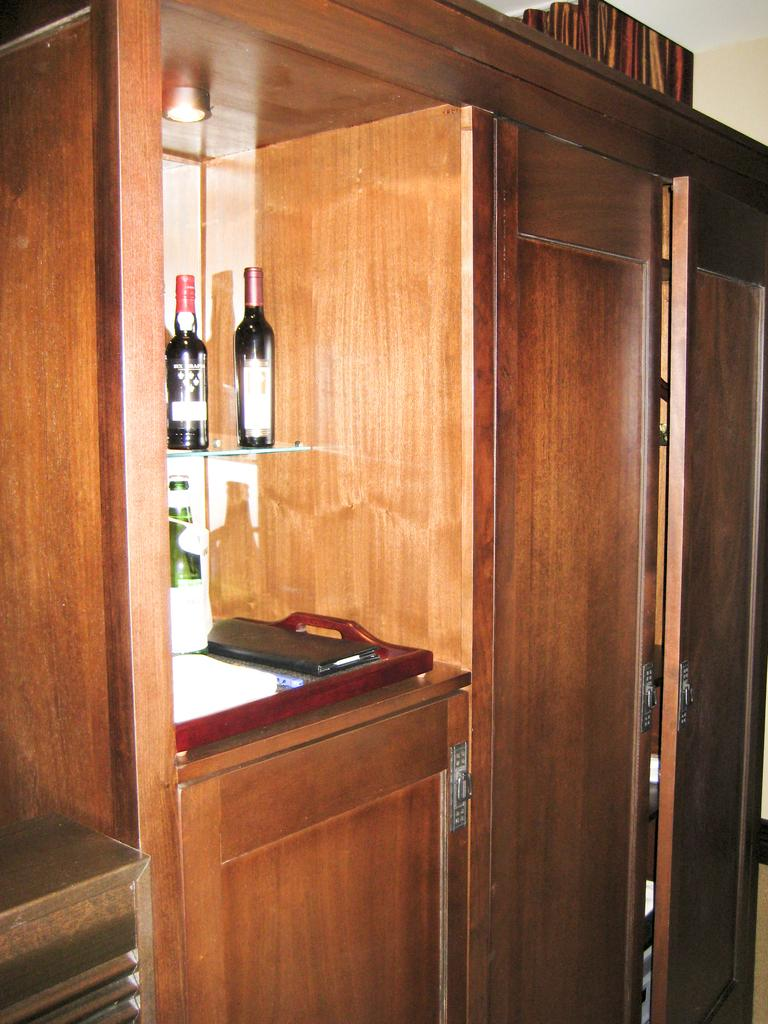What type of furniture is present in the image? There is a cupboard in the image. Can you describe the arrangement of the furniture? There is a shelf next to the cupboard. What items can be seen on the shelf? There are bottles placed on the shelf. What type of glass is being used to cover the shirt on the shelf? There is no glass or shirt present on the shelf in the image; only bottles are visible. 